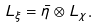<formula> <loc_0><loc_0><loc_500><loc_500>L _ { \xi } = \bar { \eta } \otimes L _ { \chi } .</formula> 